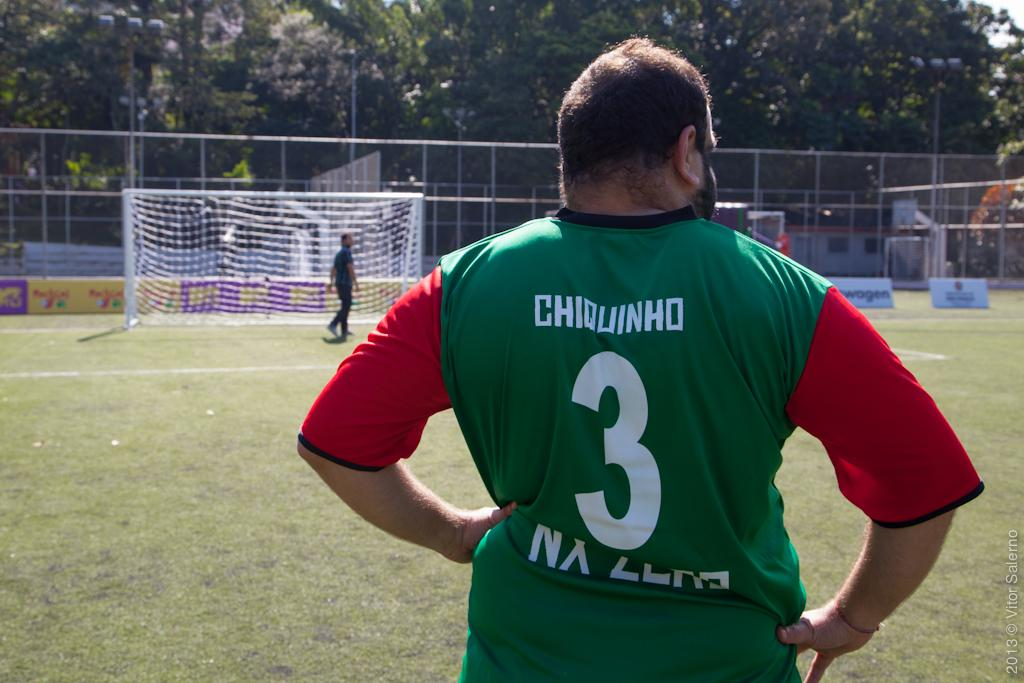<image>
Provide a brief description of the given image. A man in a shirt with the number 3 on the  back stands in front of a soccer goal. 